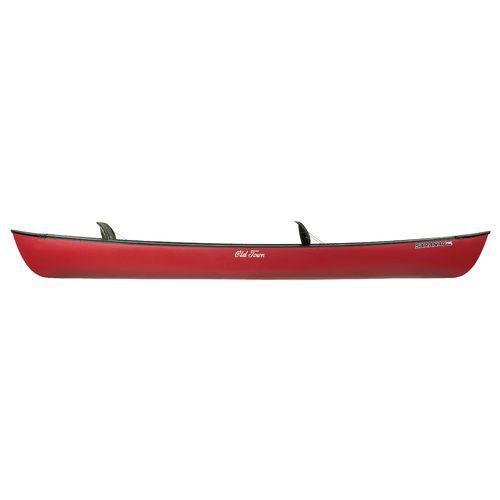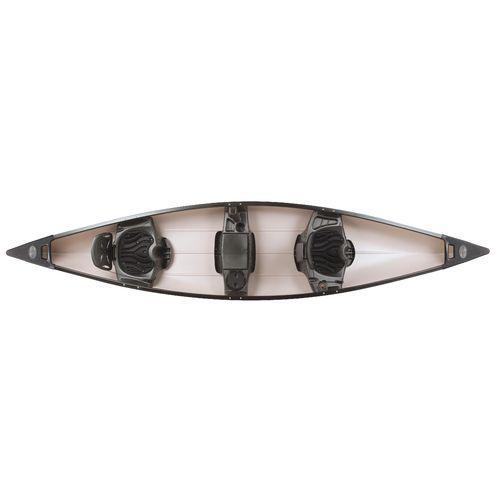The first image is the image on the left, the second image is the image on the right. Examine the images to the left and right. Is the description "There are four upright boats." accurate? Answer yes or no. No. The first image is the image on the left, the second image is the image on the right. For the images shown, is this caption "One of the boats does not contain seats with backrests." true? Answer yes or no. No. 